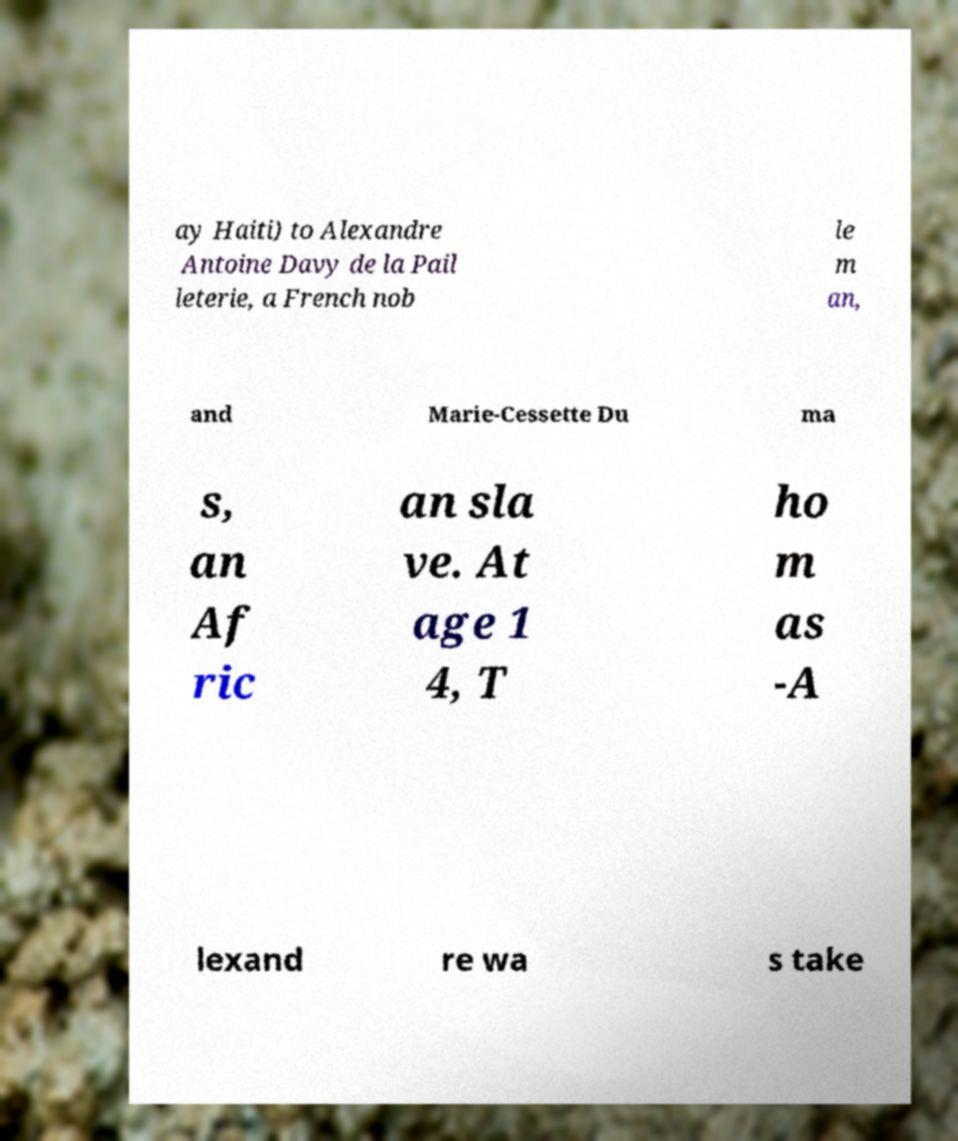Can you read and provide the text displayed in the image?This photo seems to have some interesting text. Can you extract and type it out for me? ay Haiti) to Alexandre Antoine Davy de la Pail leterie, a French nob le m an, and Marie-Cessette Du ma s, an Af ric an sla ve. At age 1 4, T ho m as -A lexand re wa s take 